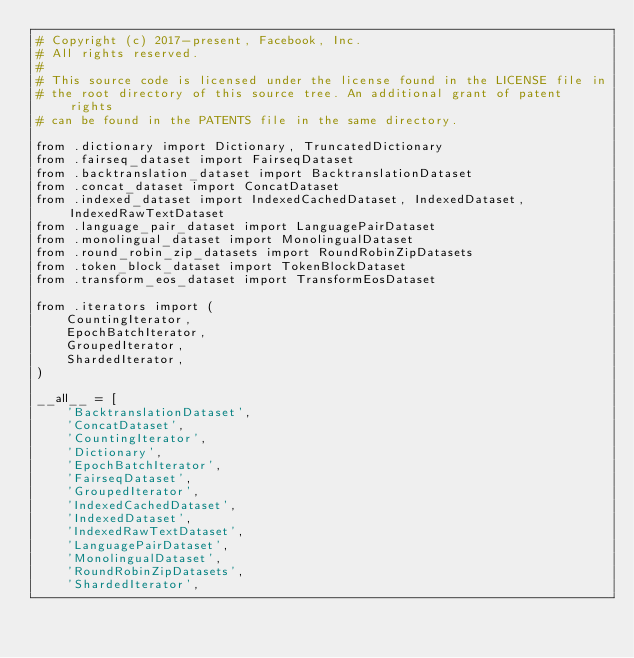<code> <loc_0><loc_0><loc_500><loc_500><_Python_># Copyright (c) 2017-present, Facebook, Inc.
# All rights reserved.
#
# This source code is licensed under the license found in the LICENSE file in
# the root directory of this source tree. An additional grant of patent rights
# can be found in the PATENTS file in the same directory.

from .dictionary import Dictionary, TruncatedDictionary
from .fairseq_dataset import FairseqDataset
from .backtranslation_dataset import BacktranslationDataset
from .concat_dataset import ConcatDataset
from .indexed_dataset import IndexedCachedDataset, IndexedDataset, IndexedRawTextDataset
from .language_pair_dataset import LanguagePairDataset
from .monolingual_dataset import MonolingualDataset
from .round_robin_zip_datasets import RoundRobinZipDatasets
from .token_block_dataset import TokenBlockDataset
from .transform_eos_dataset import TransformEosDataset

from .iterators import (
    CountingIterator,
    EpochBatchIterator,
    GroupedIterator,
    ShardedIterator,
)

__all__ = [
    'BacktranslationDataset',
    'ConcatDataset',
    'CountingIterator',
    'Dictionary',
    'EpochBatchIterator',
    'FairseqDataset',
    'GroupedIterator',
    'IndexedCachedDataset',
    'IndexedDataset',
    'IndexedRawTextDataset',
    'LanguagePairDataset',
    'MonolingualDataset',
    'RoundRobinZipDatasets',
    'ShardedIterator',</code> 